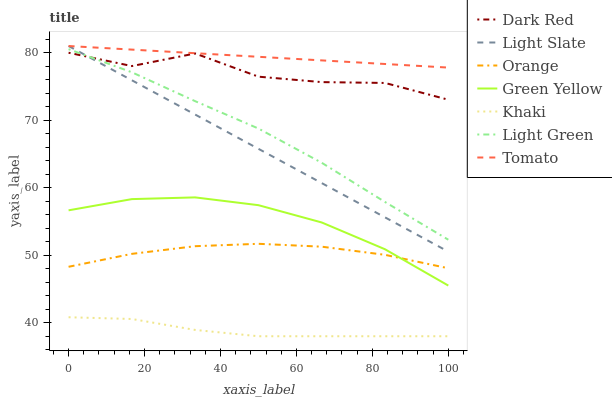Does Light Slate have the minimum area under the curve?
Answer yes or no. No. Does Light Slate have the maximum area under the curve?
Answer yes or no. No. Is Khaki the smoothest?
Answer yes or no. No. Is Khaki the roughest?
Answer yes or no. No. Does Light Slate have the lowest value?
Answer yes or no. No. Does Khaki have the highest value?
Answer yes or no. No. Is Green Yellow less than Dark Red?
Answer yes or no. Yes. Is Tomato greater than Green Yellow?
Answer yes or no. Yes. Does Green Yellow intersect Dark Red?
Answer yes or no. No. 